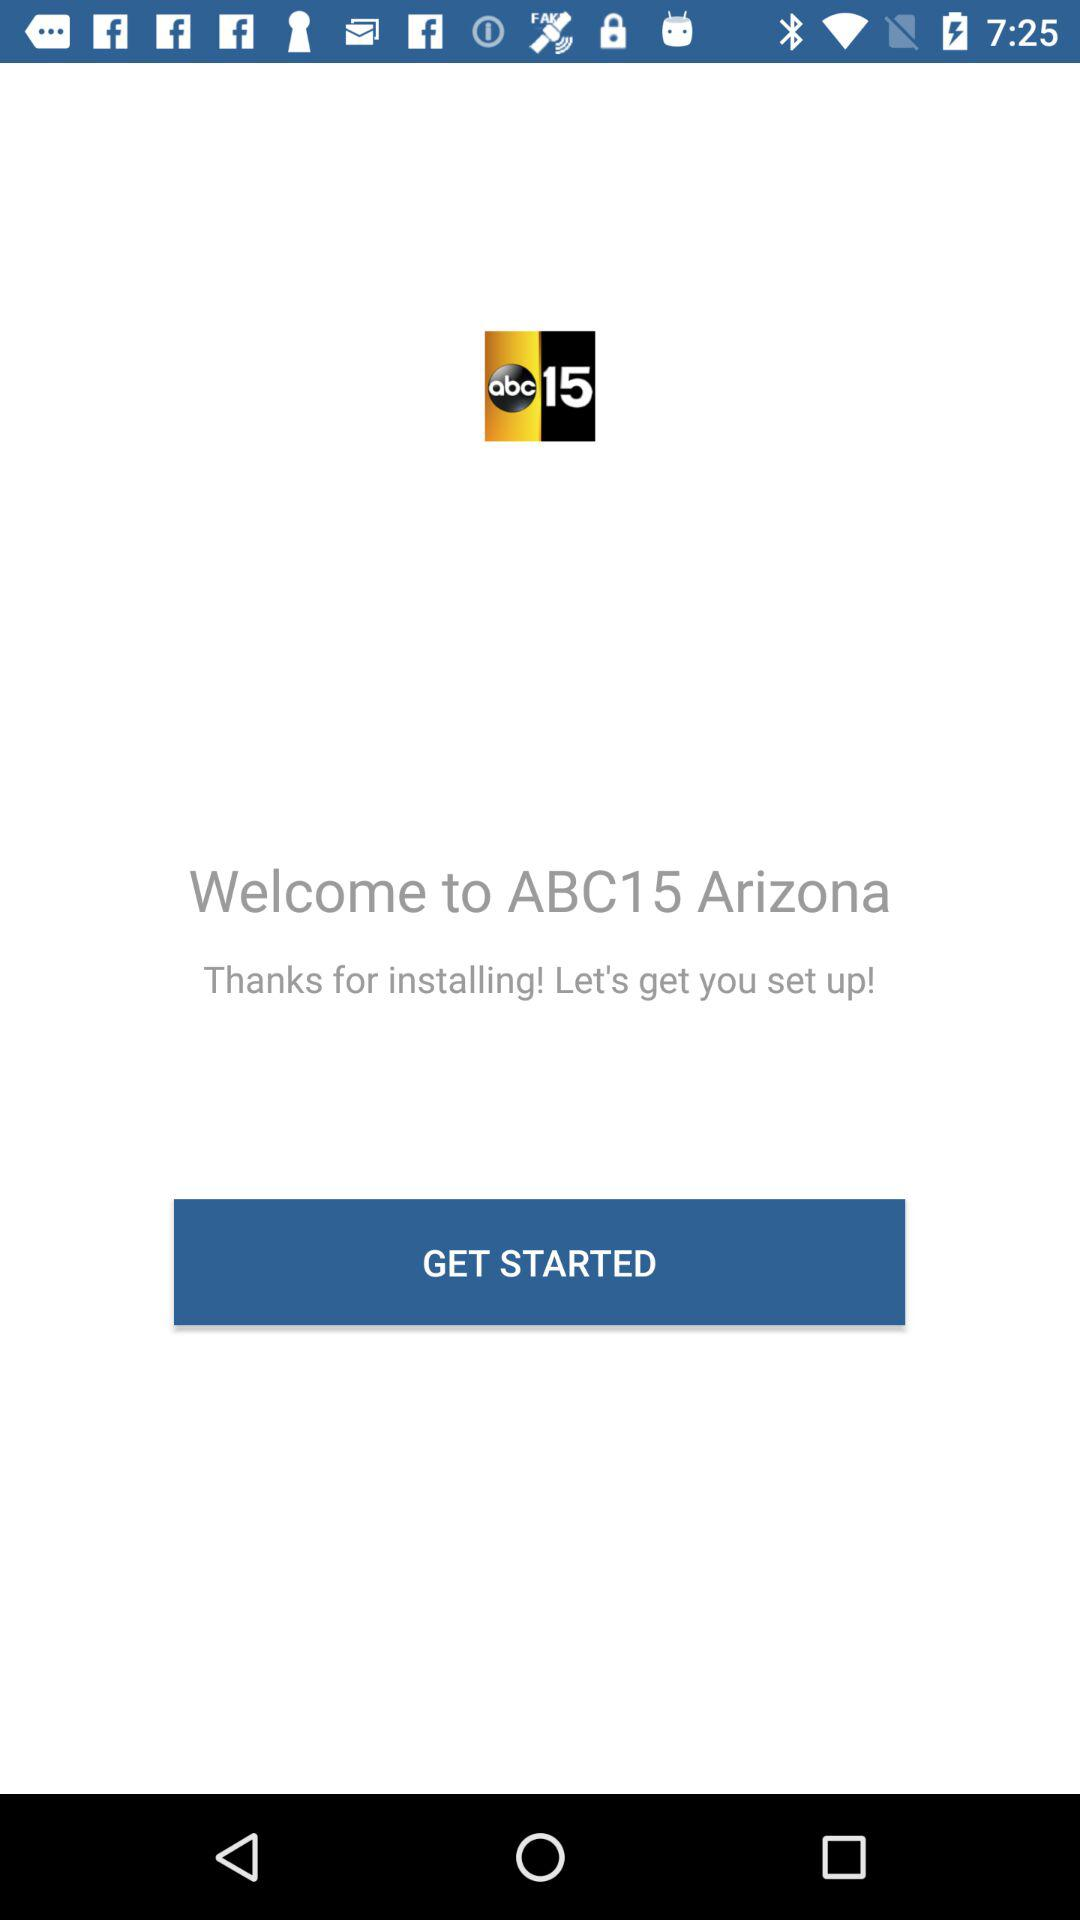What is the application name? The application name is "ABC15 Arizona". 